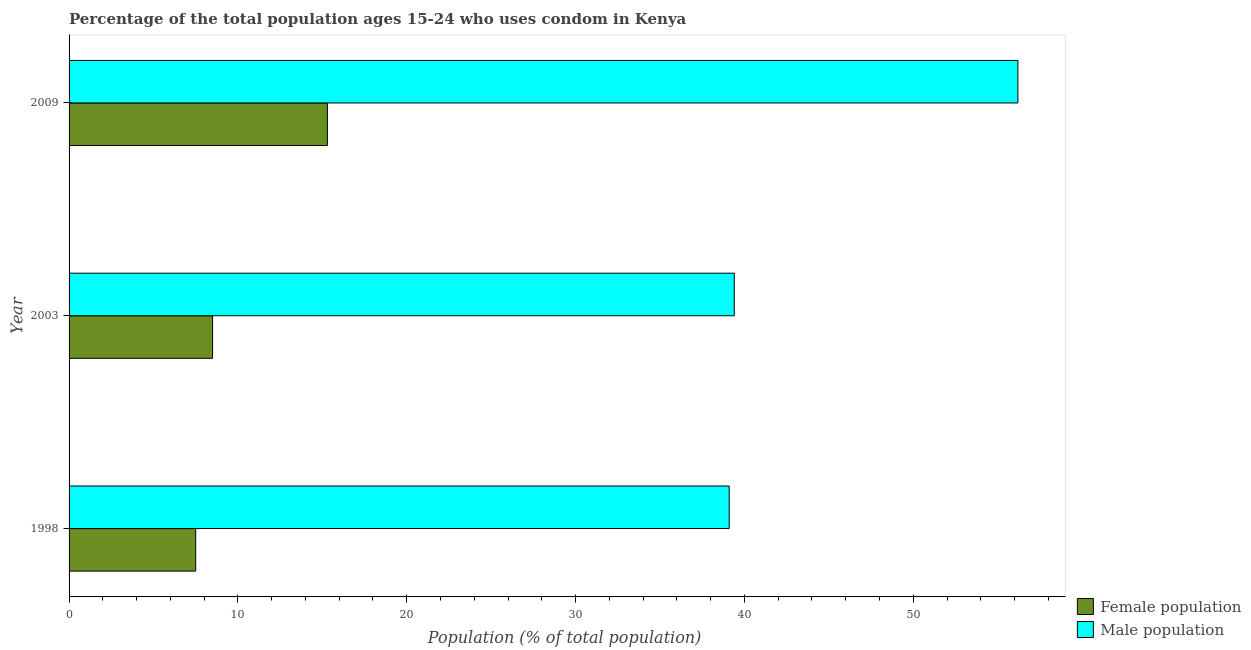How many different coloured bars are there?
Your response must be concise. 2. How many bars are there on the 1st tick from the top?
Provide a short and direct response. 2. What is the label of the 1st group of bars from the top?
Your answer should be very brief. 2009. In how many cases, is the number of bars for a given year not equal to the number of legend labels?
Provide a short and direct response. 0. What is the male population in 2009?
Provide a short and direct response. 56.2. Across all years, what is the minimum male population?
Give a very brief answer. 39.1. In which year was the male population maximum?
Your response must be concise. 2009. In which year was the female population minimum?
Ensure brevity in your answer.  1998. What is the total female population in the graph?
Provide a succinct answer. 31.3. What is the difference between the female population in 2003 and that in 2009?
Give a very brief answer. -6.8. What is the difference between the male population in 1998 and the female population in 2003?
Keep it short and to the point. 30.6. What is the average female population per year?
Ensure brevity in your answer.  10.43. In the year 2003, what is the difference between the male population and female population?
Provide a succinct answer. 30.9. In how many years, is the female population greater than 52 %?
Offer a very short reply. 0. What is the ratio of the male population in 2003 to that in 2009?
Your answer should be compact. 0.7. What is the difference between the highest and the second highest male population?
Ensure brevity in your answer.  16.8. What is the difference between the highest and the lowest male population?
Your answer should be compact. 17.1. In how many years, is the male population greater than the average male population taken over all years?
Offer a very short reply. 1. What does the 2nd bar from the top in 1998 represents?
Your answer should be very brief. Female population. What does the 2nd bar from the bottom in 1998 represents?
Ensure brevity in your answer.  Male population. Are all the bars in the graph horizontal?
Offer a very short reply. Yes. What is the difference between two consecutive major ticks on the X-axis?
Keep it short and to the point. 10. Are the values on the major ticks of X-axis written in scientific E-notation?
Make the answer very short. No. Does the graph contain grids?
Provide a succinct answer. No. How many legend labels are there?
Offer a terse response. 2. How are the legend labels stacked?
Your answer should be compact. Vertical. What is the title of the graph?
Provide a short and direct response. Percentage of the total population ages 15-24 who uses condom in Kenya. What is the label or title of the X-axis?
Provide a succinct answer. Population (% of total population) . What is the Population (% of total population)  in Female population in 1998?
Your response must be concise. 7.5. What is the Population (% of total population)  of Male population in 1998?
Ensure brevity in your answer.  39.1. What is the Population (% of total population)  of Male population in 2003?
Make the answer very short. 39.4. What is the Population (% of total population)  of Female population in 2009?
Your answer should be very brief. 15.3. What is the Population (% of total population)  of Male population in 2009?
Your answer should be very brief. 56.2. Across all years, what is the maximum Population (% of total population)  in Male population?
Ensure brevity in your answer.  56.2. Across all years, what is the minimum Population (% of total population)  of Male population?
Your response must be concise. 39.1. What is the total Population (% of total population)  of Female population in the graph?
Provide a short and direct response. 31.3. What is the total Population (% of total population)  in Male population in the graph?
Ensure brevity in your answer.  134.7. What is the difference between the Population (% of total population)  in Female population in 1998 and that in 2003?
Give a very brief answer. -1. What is the difference between the Population (% of total population)  in Female population in 1998 and that in 2009?
Your answer should be compact. -7.8. What is the difference between the Population (% of total population)  of Male population in 1998 and that in 2009?
Make the answer very short. -17.1. What is the difference between the Population (% of total population)  in Male population in 2003 and that in 2009?
Make the answer very short. -16.8. What is the difference between the Population (% of total population)  of Female population in 1998 and the Population (% of total population)  of Male population in 2003?
Offer a terse response. -31.9. What is the difference between the Population (% of total population)  in Female population in 1998 and the Population (% of total population)  in Male population in 2009?
Offer a very short reply. -48.7. What is the difference between the Population (% of total population)  in Female population in 2003 and the Population (% of total population)  in Male population in 2009?
Provide a short and direct response. -47.7. What is the average Population (% of total population)  of Female population per year?
Ensure brevity in your answer.  10.43. What is the average Population (% of total population)  in Male population per year?
Offer a terse response. 44.9. In the year 1998, what is the difference between the Population (% of total population)  of Female population and Population (% of total population)  of Male population?
Provide a short and direct response. -31.6. In the year 2003, what is the difference between the Population (% of total population)  in Female population and Population (% of total population)  in Male population?
Your response must be concise. -30.9. In the year 2009, what is the difference between the Population (% of total population)  in Female population and Population (% of total population)  in Male population?
Give a very brief answer. -40.9. What is the ratio of the Population (% of total population)  in Female population in 1998 to that in 2003?
Offer a terse response. 0.88. What is the ratio of the Population (% of total population)  of Female population in 1998 to that in 2009?
Provide a short and direct response. 0.49. What is the ratio of the Population (% of total population)  of Male population in 1998 to that in 2009?
Your response must be concise. 0.7. What is the ratio of the Population (% of total population)  of Female population in 2003 to that in 2009?
Give a very brief answer. 0.56. What is the ratio of the Population (% of total population)  in Male population in 2003 to that in 2009?
Provide a short and direct response. 0.7. What is the difference between the highest and the second highest Population (% of total population)  of Female population?
Ensure brevity in your answer.  6.8. 